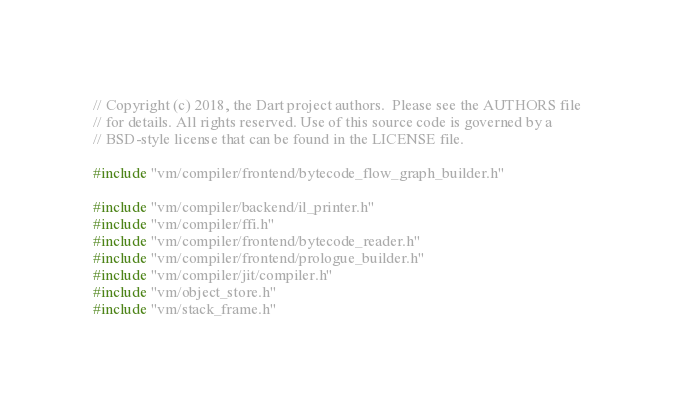<code> <loc_0><loc_0><loc_500><loc_500><_C++_>// Copyright (c) 2018, the Dart project authors.  Please see the AUTHORS file
// for details. All rights reserved. Use of this source code is governed by a
// BSD-style license that can be found in the LICENSE file.

#include "vm/compiler/frontend/bytecode_flow_graph_builder.h"

#include "vm/compiler/backend/il_printer.h"
#include "vm/compiler/ffi.h"
#include "vm/compiler/frontend/bytecode_reader.h"
#include "vm/compiler/frontend/prologue_builder.h"
#include "vm/compiler/jit/compiler.h"
#include "vm/object_store.h"
#include "vm/stack_frame.h"</code> 